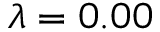<formula> <loc_0><loc_0><loc_500><loc_500>\lambda = 0 . 0 0</formula> 